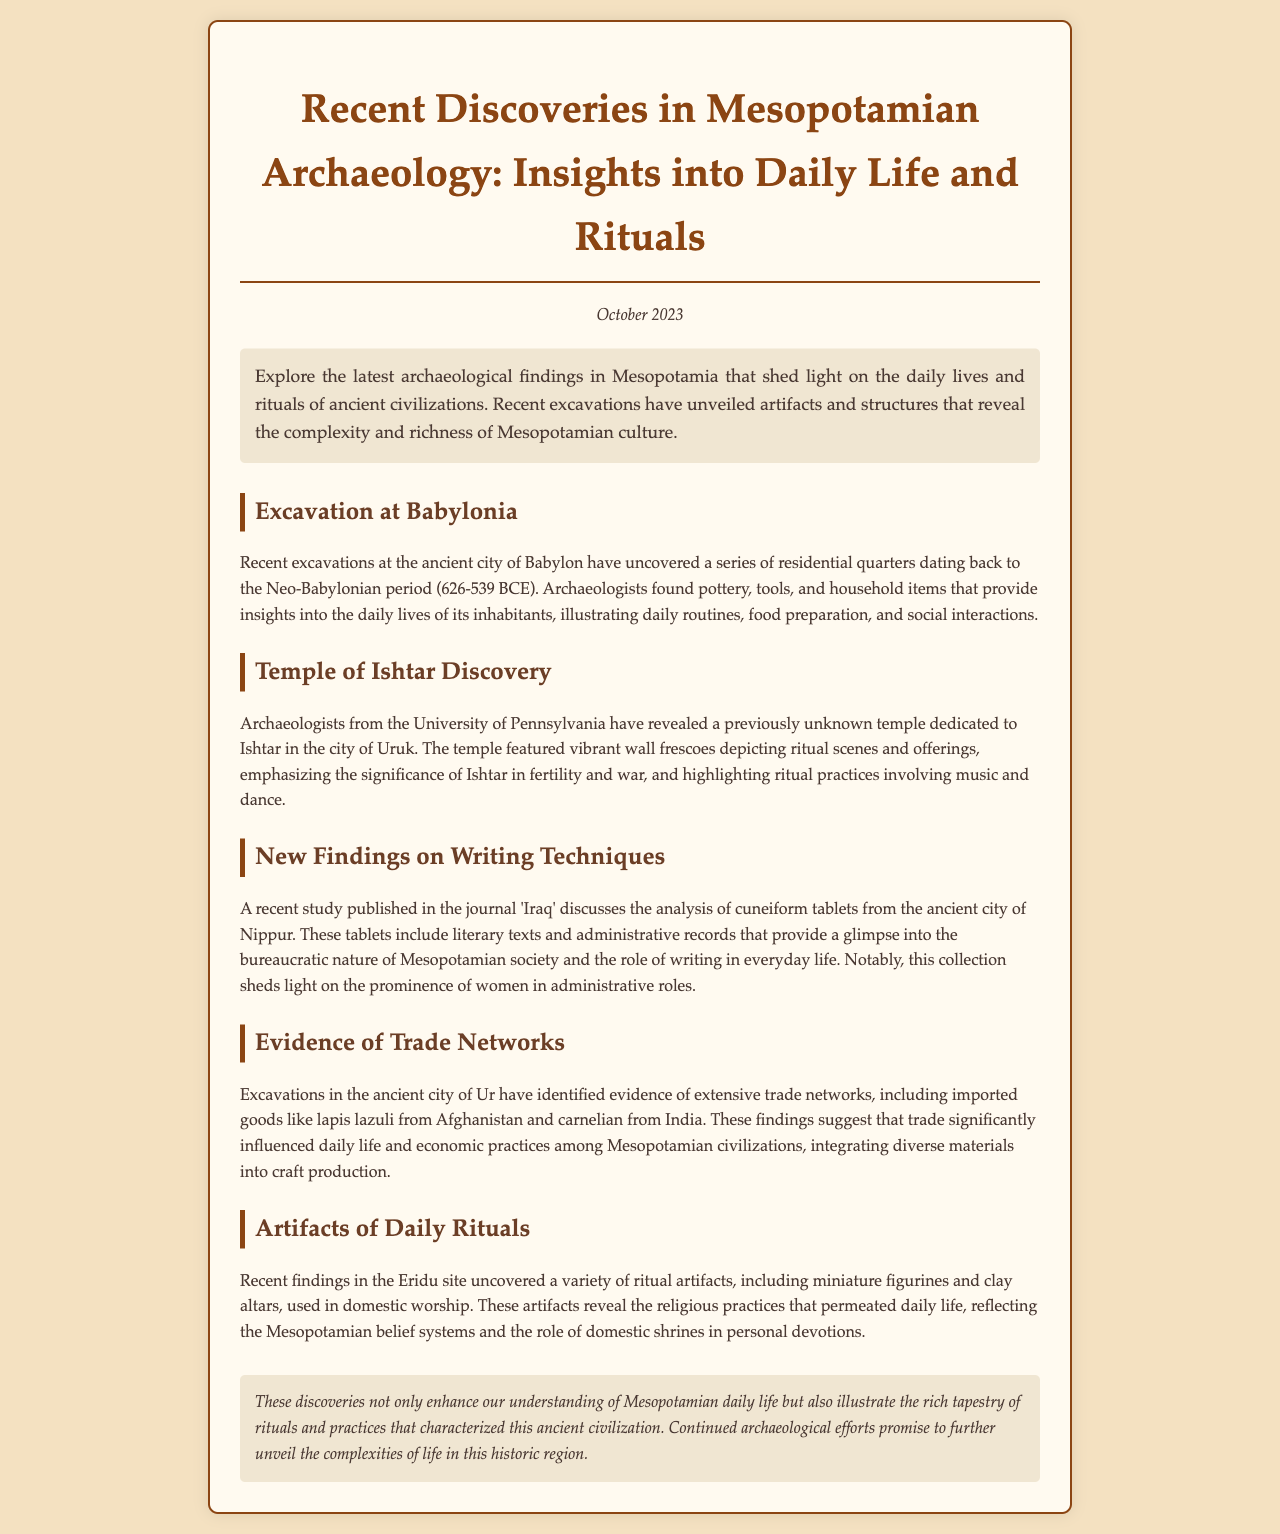What period do the residential quarters in Babylon date back to? The residential quarters date back to the Neo-Babylonian period (626-539 BCE) as mentioned in the section about Babylonia.
Answer: Neo-Babylonian period (626-539 BCE) Which temple was recently discovered in Uruk? The recently discovered temple is dedicated to Ishtar, as noted in the section about the Temple of Ishtar.
Answer: Ishtar What type of artifacts were uncovered at the Eridu site? The Eridu site revealed a variety of ritual artifacts, including miniature figurines and clay altars, mentioned in the section on daily rituals.
Answer: Miniature figurines and clay altars What significant resource was imported from Afghanistan? The findings indicated imported goods like lapis lazuli from Afghanistan, discussed in the section on trade networks.
Answer: Lapis lazuli How did the findings in Nippur highlight social structures? The cuneiform tablets shed light on the prominence of women in administrative roles, as explained in the writing techniques section.
Answer: Women in administrative roles What was a key activity associated with the temple dedicated to Ishtar? The temple emphasized ritual practices involving music and dance, highlighted in the Temple of Ishtar section.
Answer: Music and dance What do the recent discoveries enhance our understanding of? The discoveries enhance our understanding of Mesopotamian daily life, as stated in the conclusion.
Answer: Mesopotamian daily life Which university's archaeologists revealed the temple dedicated to Ishtar? Archaeologists from the University of Pennsylvania revealed the temple, as noted in the section about the Temple of Ishtar.
Answer: University of Pennsylvania 